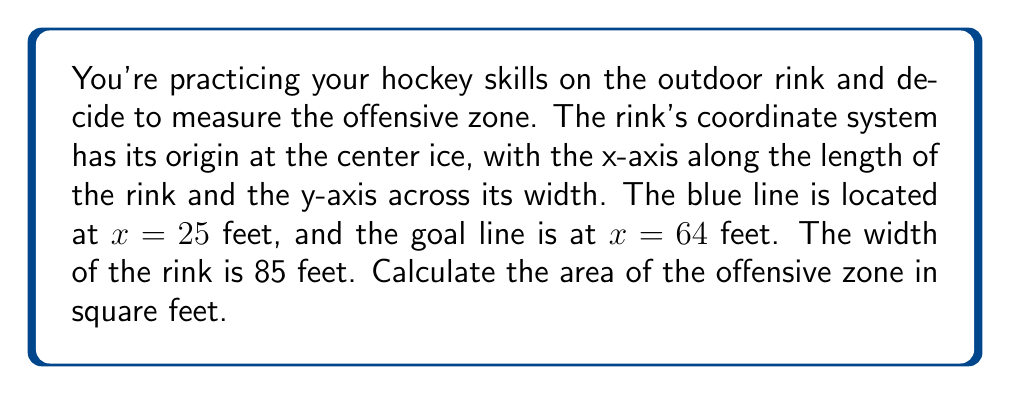Provide a solution to this math problem. Let's approach this step-by-step:

1) The offensive zone is a rectangular area of the ice hockey rink between the blue line and the end boards.

2) We're given the following information:
   - The blue line is at $x = 25$ feet
   - The goal line is at $x = 64$ feet
   - The width of the rink is 85 feet

3) The length of the offensive zone is the distance from the blue line to the end boards. The end boards are typically 11 feet beyond the goal line. So:
   
   Length = $(64 + 11) - 25 = 50$ feet

4) The width of the offensive zone is the same as the width of the rink, which is 85 feet.

5) The area of a rectangle is given by the formula:

   $$A = l \times w$$

   where $A$ is the area, $l$ is the length, and $w$ is the width.

6) Substituting our values:

   $$A = 50 \text{ ft} \times 85 \text{ ft} = 4250 \text{ sq ft}$$

[asy]
unitsize(2.5);
draw((0,0)--(4,0)--(4,3.4)--(0,3.4)--cycle);
draw((1,0)--(1,3.4), blue);
draw((3.56,0)--(3.56,3.4), red);
label("Blue line", (1,3.6), N);
label("Goal line", (3.56,3.6), N);
label("25 ft", (0.5,-0.2), S);
label("39 ft", (2.28,-0.2), S);
label("11 ft", (3.78,-0.2), S);
label("85 ft", (-0.2,1.7), W);
[/asy]
Answer: The area of the offensive zone is 4250 square feet. 